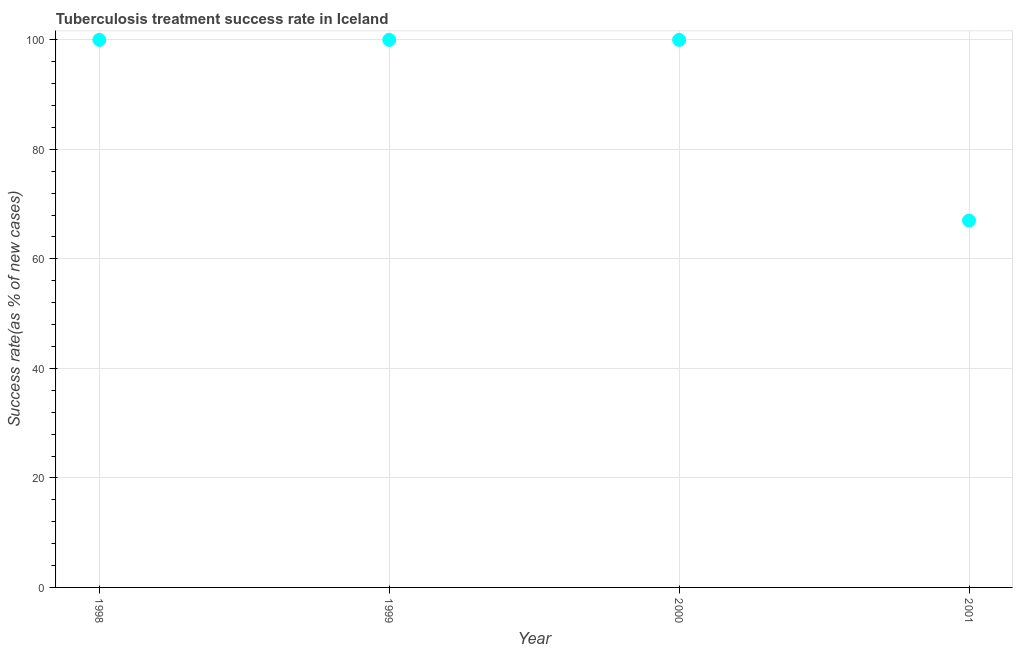What is the tuberculosis treatment success rate in 2001?
Offer a very short reply. 67. Across all years, what is the maximum tuberculosis treatment success rate?
Offer a terse response. 100. Across all years, what is the minimum tuberculosis treatment success rate?
Offer a very short reply. 67. What is the sum of the tuberculosis treatment success rate?
Provide a succinct answer. 367. What is the difference between the tuberculosis treatment success rate in 1998 and 2000?
Your answer should be very brief. 0. What is the average tuberculosis treatment success rate per year?
Your response must be concise. 91.75. What is the median tuberculosis treatment success rate?
Provide a succinct answer. 100. Do a majority of the years between 2000 and 1998 (inclusive) have tuberculosis treatment success rate greater than 92 %?
Keep it short and to the point. No. What is the ratio of the tuberculosis treatment success rate in 1999 to that in 2000?
Make the answer very short. 1. Is the sum of the tuberculosis treatment success rate in 1998 and 1999 greater than the maximum tuberculosis treatment success rate across all years?
Your answer should be compact. Yes. What is the difference between the highest and the lowest tuberculosis treatment success rate?
Ensure brevity in your answer.  33. In how many years, is the tuberculosis treatment success rate greater than the average tuberculosis treatment success rate taken over all years?
Provide a succinct answer. 3. Does the tuberculosis treatment success rate monotonically increase over the years?
Ensure brevity in your answer.  No. Are the values on the major ticks of Y-axis written in scientific E-notation?
Offer a terse response. No. What is the title of the graph?
Offer a very short reply. Tuberculosis treatment success rate in Iceland. What is the label or title of the Y-axis?
Make the answer very short. Success rate(as % of new cases). What is the Success rate(as % of new cases) in 2000?
Your answer should be compact. 100. What is the Success rate(as % of new cases) in 2001?
Provide a short and direct response. 67. What is the difference between the Success rate(as % of new cases) in 1999 and 2001?
Provide a succinct answer. 33. What is the difference between the Success rate(as % of new cases) in 2000 and 2001?
Make the answer very short. 33. What is the ratio of the Success rate(as % of new cases) in 1998 to that in 1999?
Keep it short and to the point. 1. What is the ratio of the Success rate(as % of new cases) in 1998 to that in 2001?
Offer a very short reply. 1.49. What is the ratio of the Success rate(as % of new cases) in 1999 to that in 2000?
Your answer should be very brief. 1. What is the ratio of the Success rate(as % of new cases) in 1999 to that in 2001?
Provide a succinct answer. 1.49. What is the ratio of the Success rate(as % of new cases) in 2000 to that in 2001?
Provide a succinct answer. 1.49. 